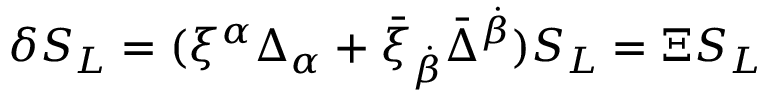Convert formula to latex. <formula><loc_0><loc_0><loc_500><loc_500>\delta S _ { L } = ( \xi ^ { \alpha } \Delta _ { \alpha } + \bar { \xi } _ { \dot { \beta } } \bar { \Delta } ^ { \dot { \beta } } ) S _ { L } = \Xi S _ { L }</formula> 